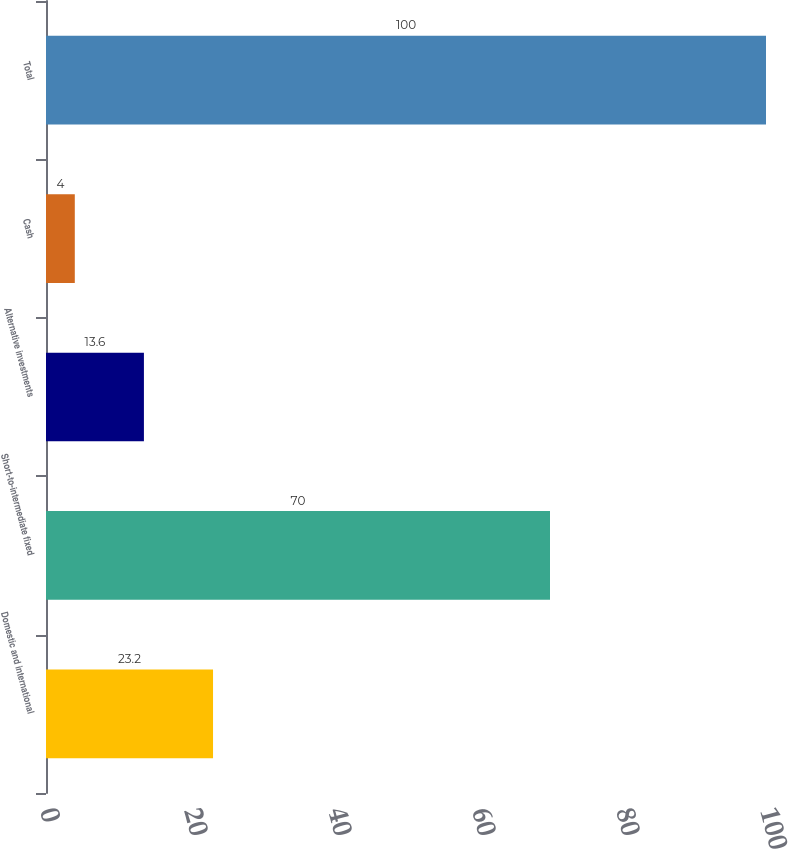<chart> <loc_0><loc_0><loc_500><loc_500><bar_chart><fcel>Domestic and international<fcel>Short-to-intermediate fixed<fcel>Alternative investments<fcel>Cash<fcel>Total<nl><fcel>23.2<fcel>70<fcel>13.6<fcel>4<fcel>100<nl></chart> 